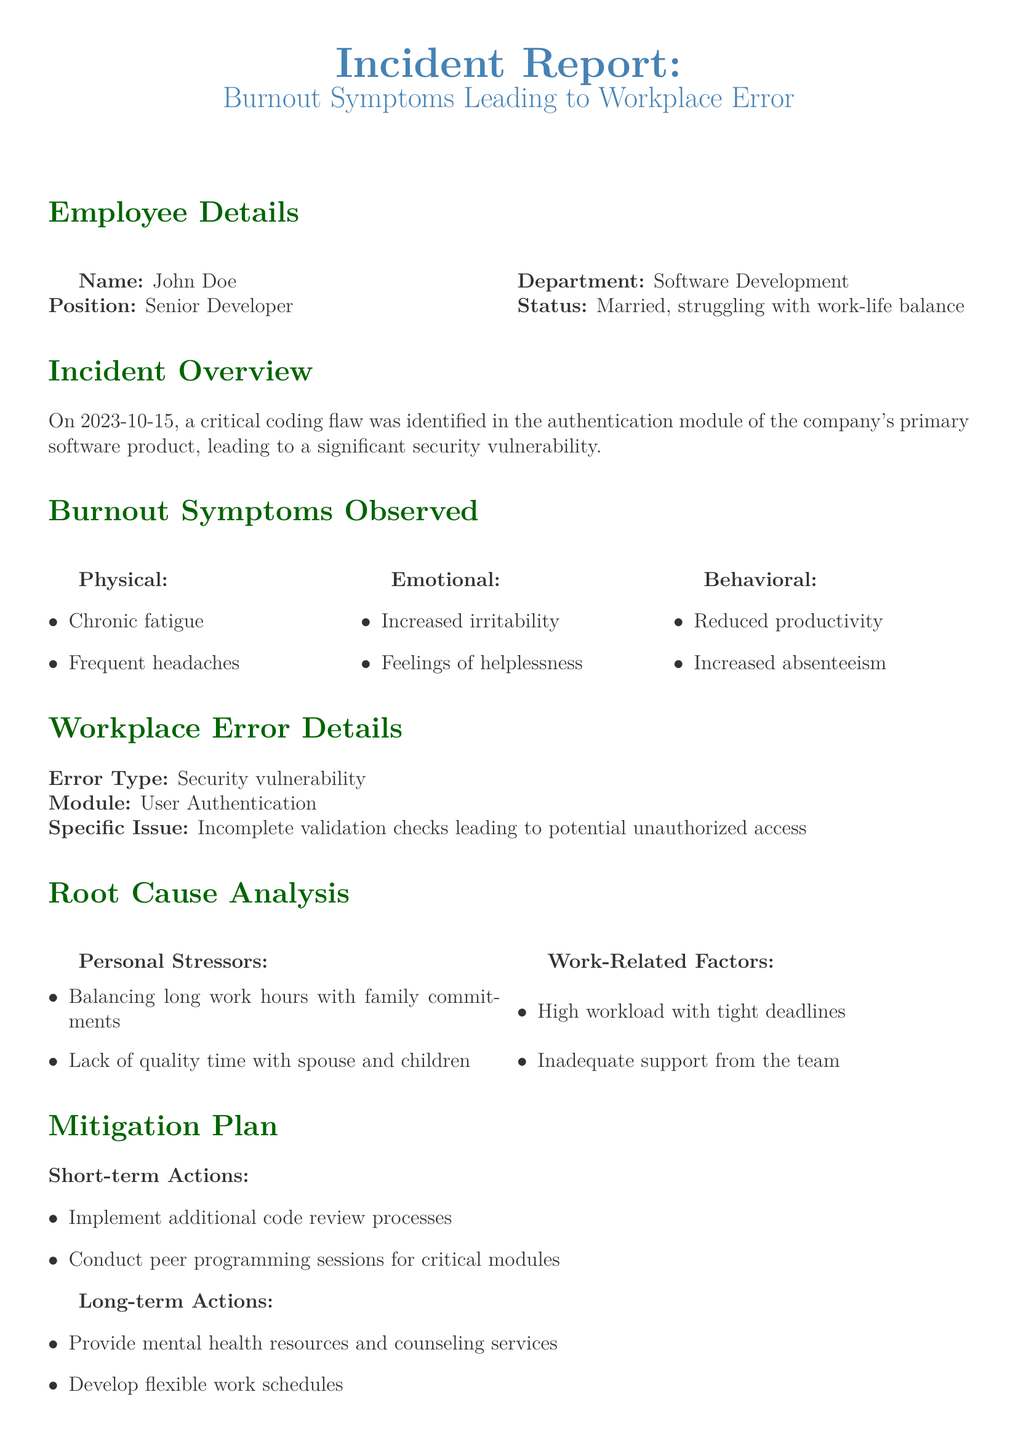What is the name of the employee involved in the incident? The employee's name is mentioned in the Employee Details section of the document.
Answer: John Doe What position does the employee hold? The individual's position is listed under Employee Details.
Answer: Senior Developer What date did the incident occur? The specific date of the incident is highlighted in the Incident Overview section.
Answer: 2023-10-15 What type of error was identified in the incident? The specific type of error is outlined in the Workplace Error Details section.
Answer: Security vulnerability What were the observed emotional symptoms of burnout? Emotional symptoms are listed in the Burnout Symptoms Observed section, providing insight into the employee's state.
Answer: Increased irritability What short-term action is proposed in the Mitigation Plan? The Mitigation Plan includes various actions, one of which is specified in the short-term section.
Answer: Implement additional code review processes What is one personal stressor identified in the Root Cause Analysis? Personal stressors are detailed in the Root Cause Analysis section, highlighting factors affecting the employee.
Answer: Balancing long work hours with family commitments What long-term action involves employee scheduling flexibility? Long-term actions include various suggestions, with one focused on work schedules.
Answer: Develop flexible work schedules What is the overall conclusion mentioned in the document? The conclusion encapsulates the main takeaway from the incident report.
Answer: The significant impact of burnout on workplace performance 